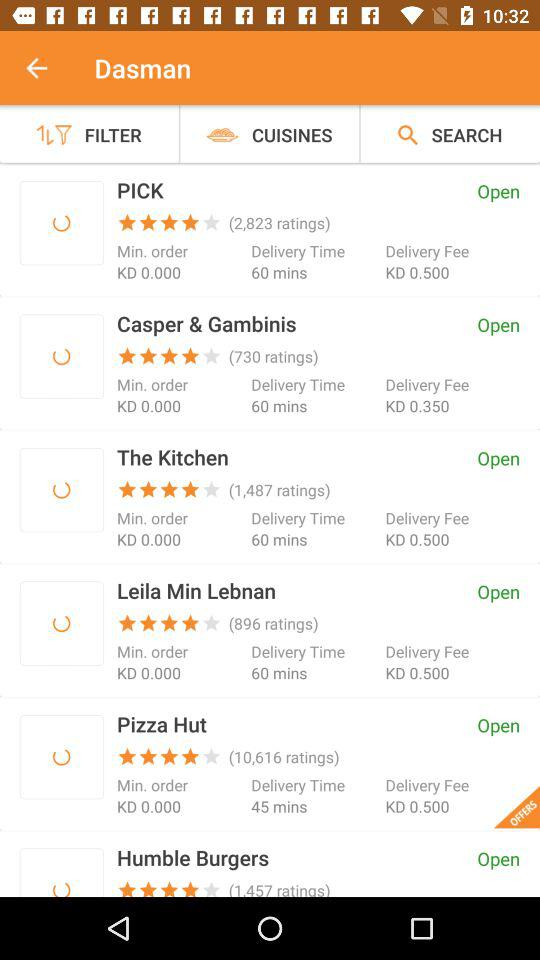What is the status of "The Kitchen" store? The status of "The Kitchen" store is open. 